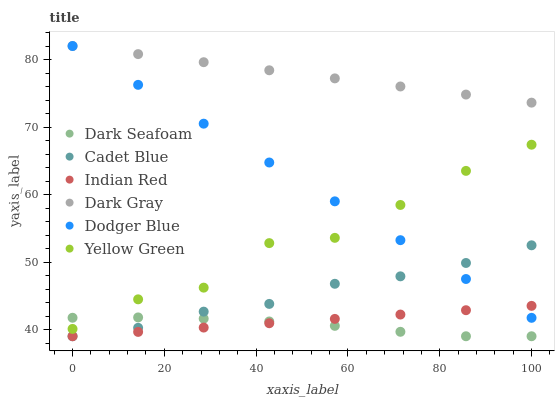Does Dark Seafoam have the minimum area under the curve?
Answer yes or no. Yes. Does Dark Gray have the maximum area under the curve?
Answer yes or no. Yes. Does Yellow Green have the minimum area under the curve?
Answer yes or no. No. Does Yellow Green have the maximum area under the curve?
Answer yes or no. No. Is Dark Gray the smoothest?
Answer yes or no. Yes. Is Yellow Green the roughest?
Answer yes or no. Yes. Is Yellow Green the smoothest?
Answer yes or no. No. Is Dark Gray the roughest?
Answer yes or no. No. Does Cadet Blue have the lowest value?
Answer yes or no. Yes. Does Yellow Green have the lowest value?
Answer yes or no. No. Does Dodger Blue have the highest value?
Answer yes or no. Yes. Does Yellow Green have the highest value?
Answer yes or no. No. Is Indian Red less than Yellow Green?
Answer yes or no. Yes. Is Dark Gray greater than Yellow Green?
Answer yes or no. Yes. Does Cadet Blue intersect Dodger Blue?
Answer yes or no. Yes. Is Cadet Blue less than Dodger Blue?
Answer yes or no. No. Is Cadet Blue greater than Dodger Blue?
Answer yes or no. No. Does Indian Red intersect Yellow Green?
Answer yes or no. No. 